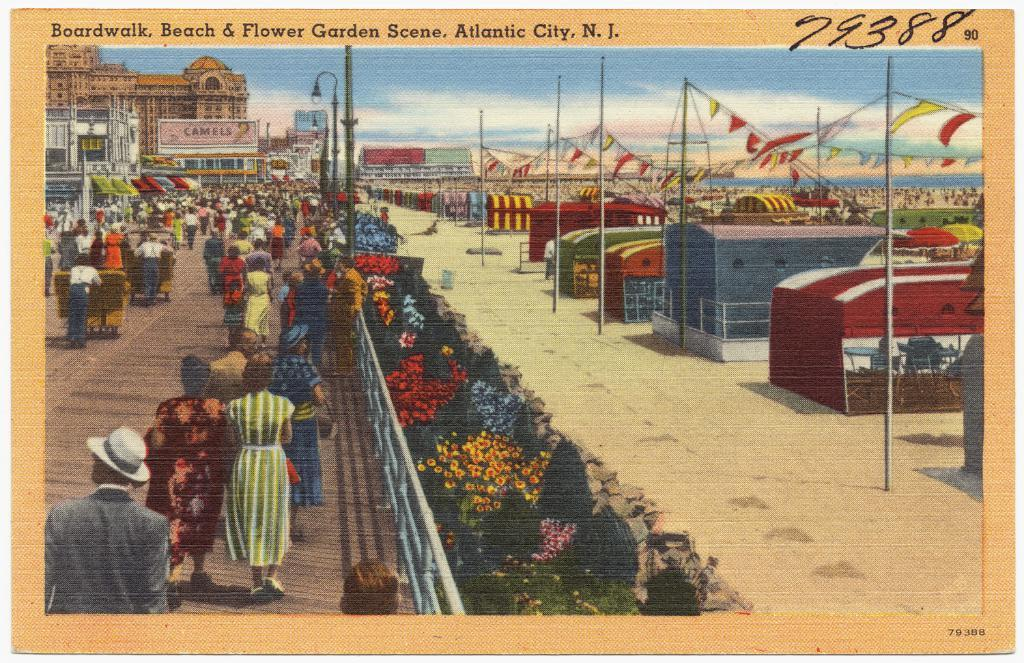Provide a one-sentence caption for the provided image. Art picture of a boardwalk, beach, and flower garden scene. 